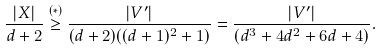Convert formula to latex. <formula><loc_0><loc_0><loc_500><loc_500>\frac { | X | } { d + 2 } \stackrel { ( * ) } { \geq } \frac { | V ^ { \prime } | } { ( d + 2 ) ( ( d + 1 ) ^ { 2 } + 1 ) } = \frac { | V ^ { \prime } | } { ( d ^ { 3 } + 4 d ^ { 2 } + 6 d + 4 ) } .</formula> 